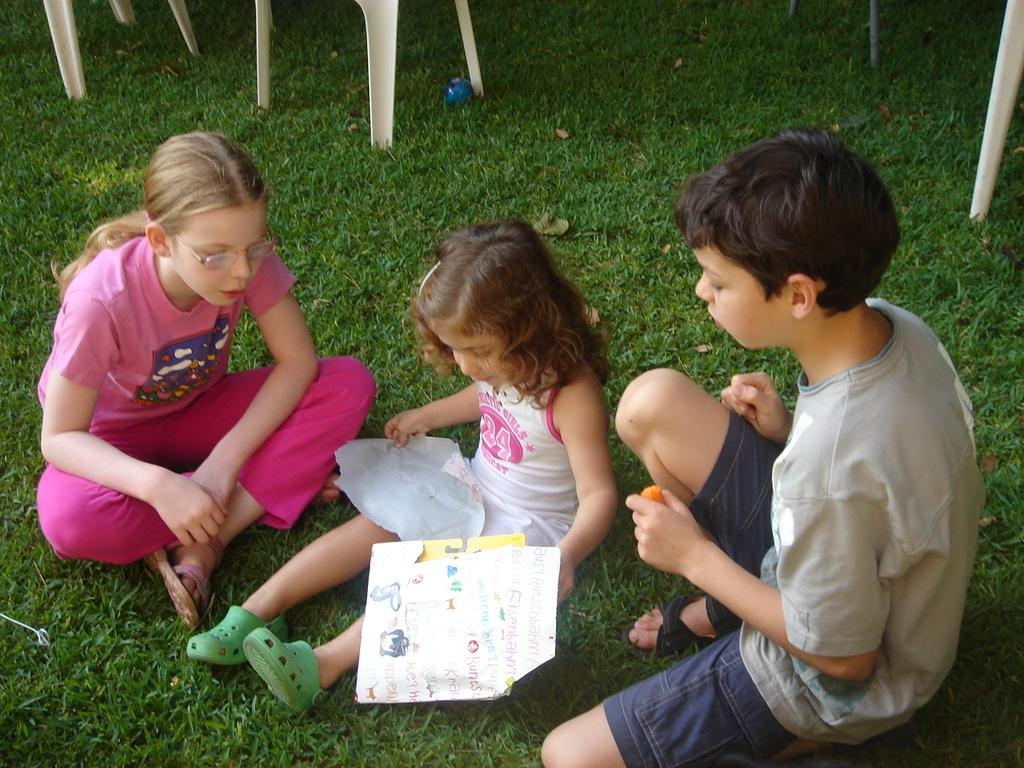How many children are present in the image? There are three children in the image, two little girls and a boy. What are the children doing in the image? The children are sitting on the grassland. What can be seen in the background of the image? There are chairs visible in the background. What type of vegetable is the boy holding in the image? There is no vegetable present in the image; the children are sitting on the grassland without any visible objects. 